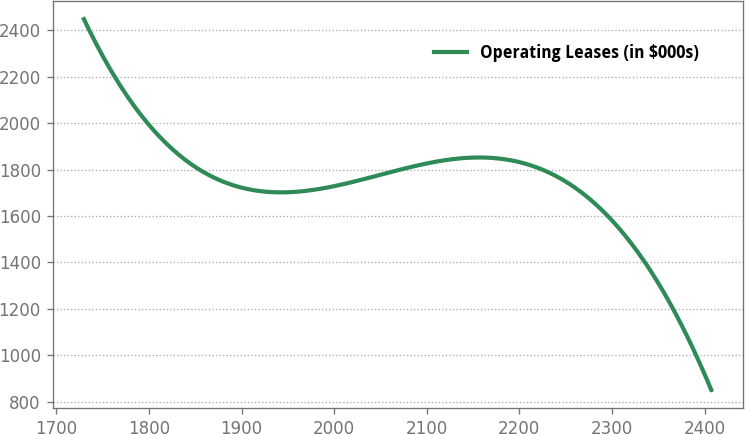Convert chart to OTSL. <chart><loc_0><loc_0><loc_500><loc_500><line_chart><ecel><fcel>Operating Leases (in $000s)<nl><fcel>1729.62<fcel>2448.61<nl><fcel>1797.38<fcel>2004.91<nl><fcel>2128.19<fcel>1845.21<nl><fcel>2272.3<fcel>1685.51<nl><fcel>2407.21<fcel>851.57<nl></chart> 